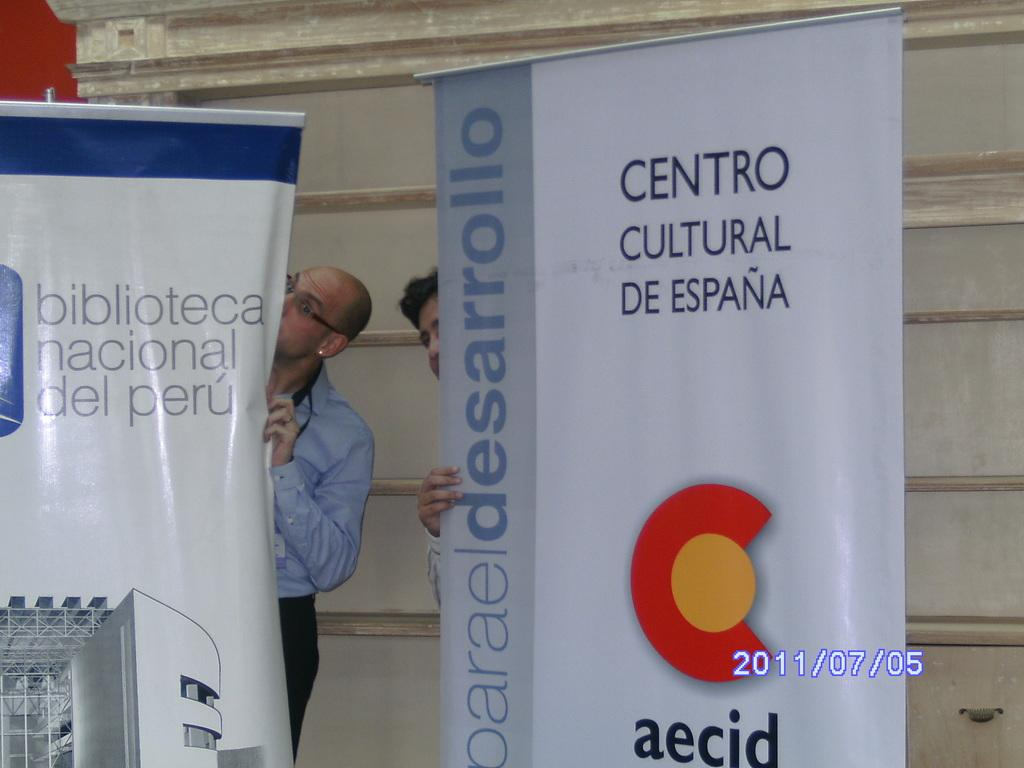<image>
Write a terse but informative summary of the picture. Two standees with people behind them, one says "Centro Cultural De Espana." 